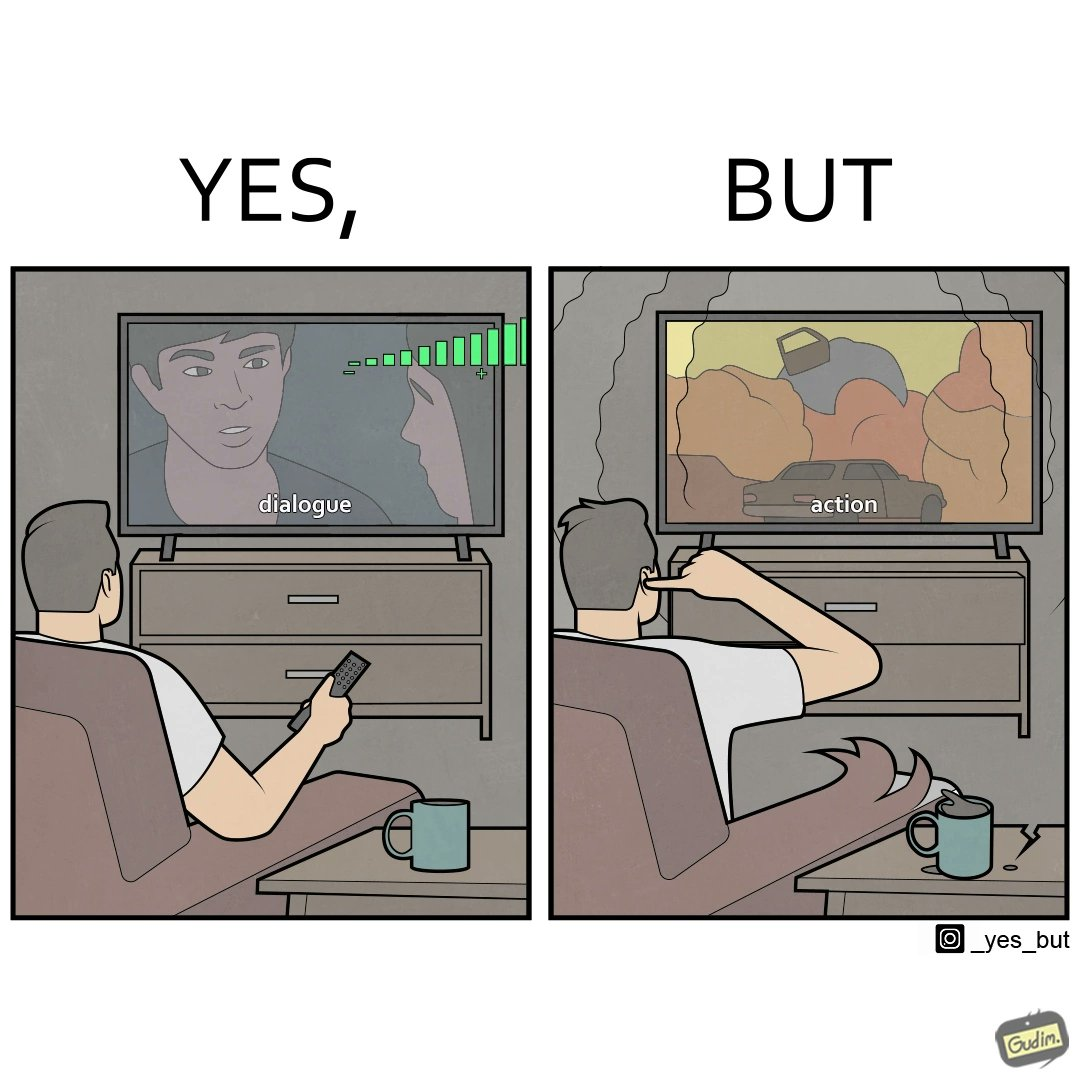Why is this image considered satirical? The action scenes of the movies or TV programs are mostly low in sound and people aren't able to hear them properly but in the action scenes due to the background music and other noise the sound becomes unbearable to some peoples 